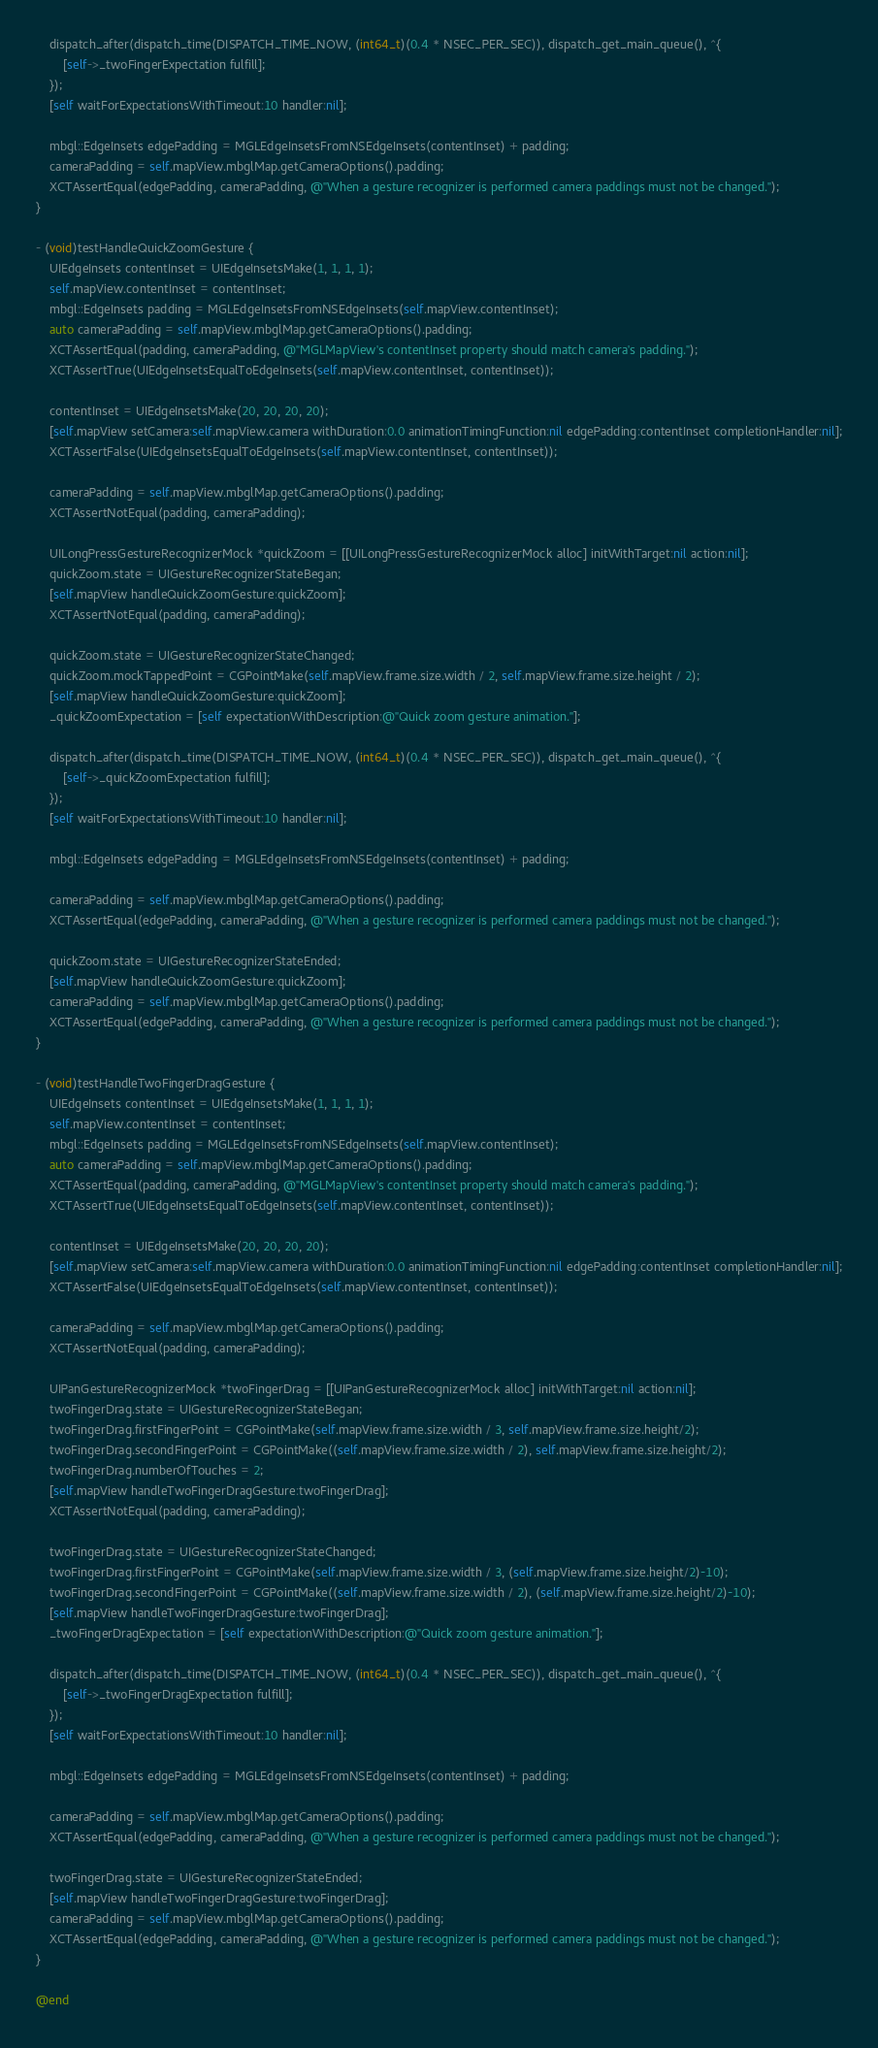<code> <loc_0><loc_0><loc_500><loc_500><_ObjectiveC_>    dispatch_after(dispatch_time(DISPATCH_TIME_NOW, (int64_t)(0.4 * NSEC_PER_SEC)), dispatch_get_main_queue(), ^{
        [self->_twoFingerExpectation fulfill];
    });
    [self waitForExpectationsWithTimeout:10 handler:nil];

    mbgl::EdgeInsets edgePadding = MGLEdgeInsetsFromNSEdgeInsets(contentInset) + padding;
    cameraPadding = self.mapView.mbglMap.getCameraOptions().padding;
    XCTAssertEqual(edgePadding, cameraPadding, @"When a gesture recognizer is performed camera paddings must not be changed.");
}

- (void)testHandleQuickZoomGesture {
    UIEdgeInsets contentInset = UIEdgeInsetsMake(1, 1, 1, 1);
    self.mapView.contentInset = contentInset;
    mbgl::EdgeInsets padding = MGLEdgeInsetsFromNSEdgeInsets(self.mapView.contentInset);
    auto cameraPadding = self.mapView.mbglMap.getCameraOptions().padding;
    XCTAssertEqual(padding, cameraPadding, @"MGLMapView's contentInset property should match camera's padding.");
    XCTAssertTrue(UIEdgeInsetsEqualToEdgeInsets(self.mapView.contentInset, contentInset));
    
    contentInset = UIEdgeInsetsMake(20, 20, 20, 20);
    [self.mapView setCamera:self.mapView.camera withDuration:0.0 animationTimingFunction:nil edgePadding:contentInset completionHandler:nil];
    XCTAssertFalse(UIEdgeInsetsEqualToEdgeInsets(self.mapView.contentInset, contentInset));
    
    cameraPadding = self.mapView.mbglMap.getCameraOptions().padding;
    XCTAssertNotEqual(padding, cameraPadding);
    
    UILongPressGestureRecognizerMock *quickZoom = [[UILongPressGestureRecognizerMock alloc] initWithTarget:nil action:nil];
    quickZoom.state = UIGestureRecognizerStateBegan;
    [self.mapView handleQuickZoomGesture:quickZoom];
    XCTAssertNotEqual(padding, cameraPadding);
    
    quickZoom.state = UIGestureRecognizerStateChanged;
    quickZoom.mockTappedPoint = CGPointMake(self.mapView.frame.size.width / 2, self.mapView.frame.size.height / 2);
    [self.mapView handleQuickZoomGesture:quickZoom];
    _quickZoomExpectation = [self expectationWithDescription:@"Quick zoom gesture animation."];

    dispatch_after(dispatch_time(DISPATCH_TIME_NOW, (int64_t)(0.4 * NSEC_PER_SEC)), dispatch_get_main_queue(), ^{
        [self->_quickZoomExpectation fulfill];
    });
    [self waitForExpectationsWithTimeout:10 handler:nil];

    mbgl::EdgeInsets edgePadding = MGLEdgeInsetsFromNSEdgeInsets(contentInset) + padding;
    
    cameraPadding = self.mapView.mbglMap.getCameraOptions().padding;
    XCTAssertEqual(edgePadding, cameraPadding, @"When a gesture recognizer is performed camera paddings must not be changed.");
    
    quickZoom.state = UIGestureRecognizerStateEnded;
    [self.mapView handleQuickZoomGesture:quickZoom];
    cameraPadding = self.mapView.mbglMap.getCameraOptions().padding;
    XCTAssertEqual(edgePadding, cameraPadding, @"When a gesture recognizer is performed camera paddings must not be changed.");
}

- (void)testHandleTwoFingerDragGesture {
    UIEdgeInsets contentInset = UIEdgeInsetsMake(1, 1, 1, 1);
    self.mapView.contentInset = contentInset;
    mbgl::EdgeInsets padding = MGLEdgeInsetsFromNSEdgeInsets(self.mapView.contentInset);
    auto cameraPadding = self.mapView.mbglMap.getCameraOptions().padding;
    XCTAssertEqual(padding, cameraPadding, @"MGLMapView's contentInset property should match camera's padding.");
    XCTAssertTrue(UIEdgeInsetsEqualToEdgeInsets(self.mapView.contentInset, contentInset));
    
    contentInset = UIEdgeInsetsMake(20, 20, 20, 20);
    [self.mapView setCamera:self.mapView.camera withDuration:0.0 animationTimingFunction:nil edgePadding:contentInset completionHandler:nil];
    XCTAssertFalse(UIEdgeInsetsEqualToEdgeInsets(self.mapView.contentInset, contentInset));
    
    cameraPadding = self.mapView.mbglMap.getCameraOptions().padding;
    XCTAssertNotEqual(padding, cameraPadding);
    
    UIPanGestureRecognizerMock *twoFingerDrag = [[UIPanGestureRecognizerMock alloc] initWithTarget:nil action:nil];
    twoFingerDrag.state = UIGestureRecognizerStateBegan;
    twoFingerDrag.firstFingerPoint = CGPointMake(self.mapView.frame.size.width / 3, self.mapView.frame.size.height/2);
    twoFingerDrag.secondFingerPoint = CGPointMake((self.mapView.frame.size.width / 2), self.mapView.frame.size.height/2);
    twoFingerDrag.numberOfTouches = 2;
    [self.mapView handleTwoFingerDragGesture:twoFingerDrag];
    XCTAssertNotEqual(padding, cameraPadding);
    
    twoFingerDrag.state = UIGestureRecognizerStateChanged;
    twoFingerDrag.firstFingerPoint = CGPointMake(self.mapView.frame.size.width / 3, (self.mapView.frame.size.height/2)-10);
    twoFingerDrag.secondFingerPoint = CGPointMake((self.mapView.frame.size.width / 2), (self.mapView.frame.size.height/2)-10);
    [self.mapView handleTwoFingerDragGesture:twoFingerDrag];
    _twoFingerDragExpectation = [self expectationWithDescription:@"Quick zoom gesture animation."];

    dispatch_after(dispatch_time(DISPATCH_TIME_NOW, (int64_t)(0.4 * NSEC_PER_SEC)), dispatch_get_main_queue(), ^{
        [self->_twoFingerDragExpectation fulfill];
    });
    [self waitForExpectationsWithTimeout:10 handler:nil];

    mbgl::EdgeInsets edgePadding = MGLEdgeInsetsFromNSEdgeInsets(contentInset) + padding;
    
    cameraPadding = self.mapView.mbglMap.getCameraOptions().padding;
    XCTAssertEqual(edgePadding, cameraPadding, @"When a gesture recognizer is performed camera paddings must not be changed.");
    
    twoFingerDrag.state = UIGestureRecognizerStateEnded;
    [self.mapView handleTwoFingerDragGesture:twoFingerDrag];
    cameraPadding = self.mapView.mbglMap.getCameraOptions().padding;
    XCTAssertEqual(edgePadding, cameraPadding, @"When a gesture recognizer is performed camera paddings must not be changed.");
}

@end
</code> 